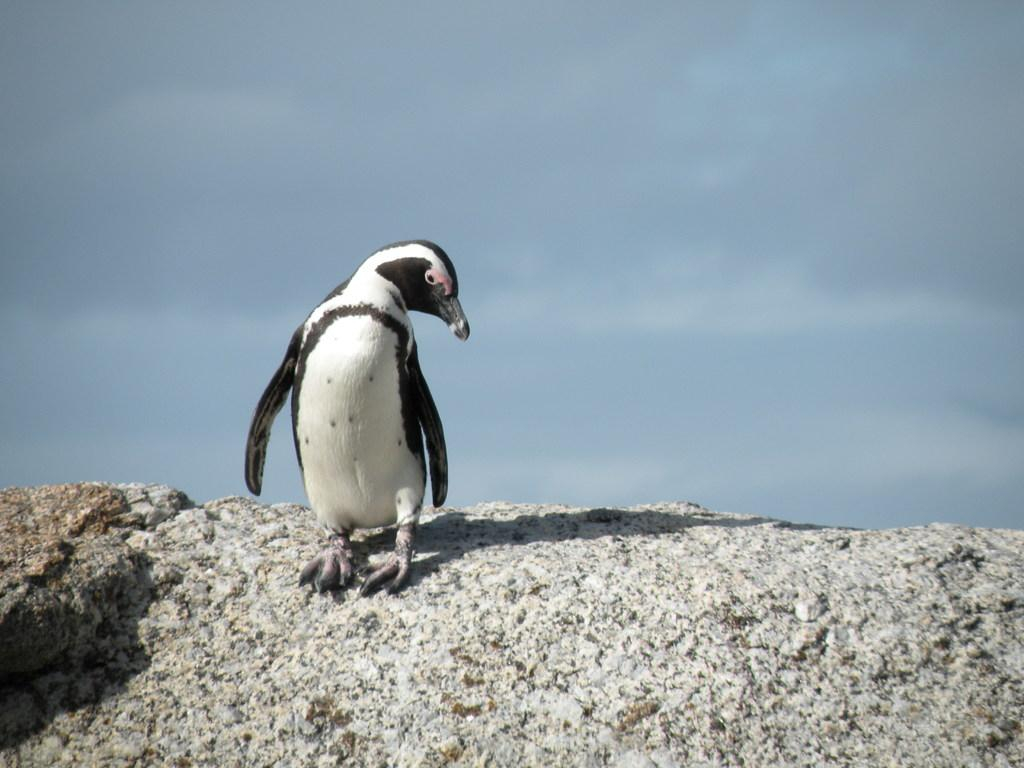What animal is present in the image? There is a penguin in the image. Where is the penguin located? The penguin is on a rock. What can be seen in the background of the image? The sky is visible in the background of the image. What type of trousers is the penguin wearing in the image? Penguins do not wear trousers, so this detail cannot be found in the image. 